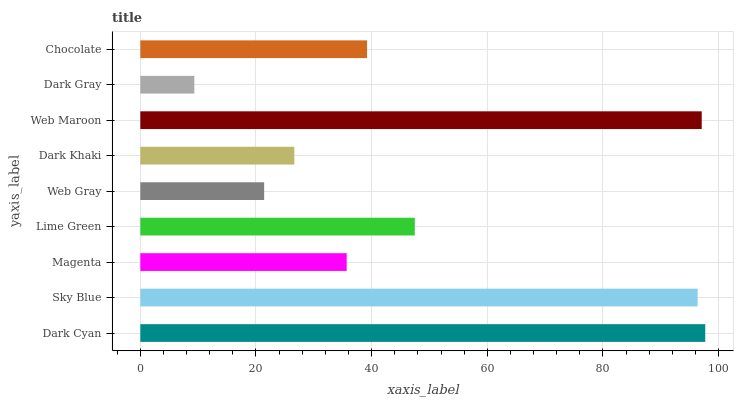Is Dark Gray the minimum?
Answer yes or no. Yes. Is Dark Cyan the maximum?
Answer yes or no. Yes. Is Sky Blue the minimum?
Answer yes or no. No. Is Sky Blue the maximum?
Answer yes or no. No. Is Dark Cyan greater than Sky Blue?
Answer yes or no. Yes. Is Sky Blue less than Dark Cyan?
Answer yes or no. Yes. Is Sky Blue greater than Dark Cyan?
Answer yes or no. No. Is Dark Cyan less than Sky Blue?
Answer yes or no. No. Is Chocolate the high median?
Answer yes or no. Yes. Is Chocolate the low median?
Answer yes or no. Yes. Is Dark Gray the high median?
Answer yes or no. No. Is Web Gray the low median?
Answer yes or no. No. 